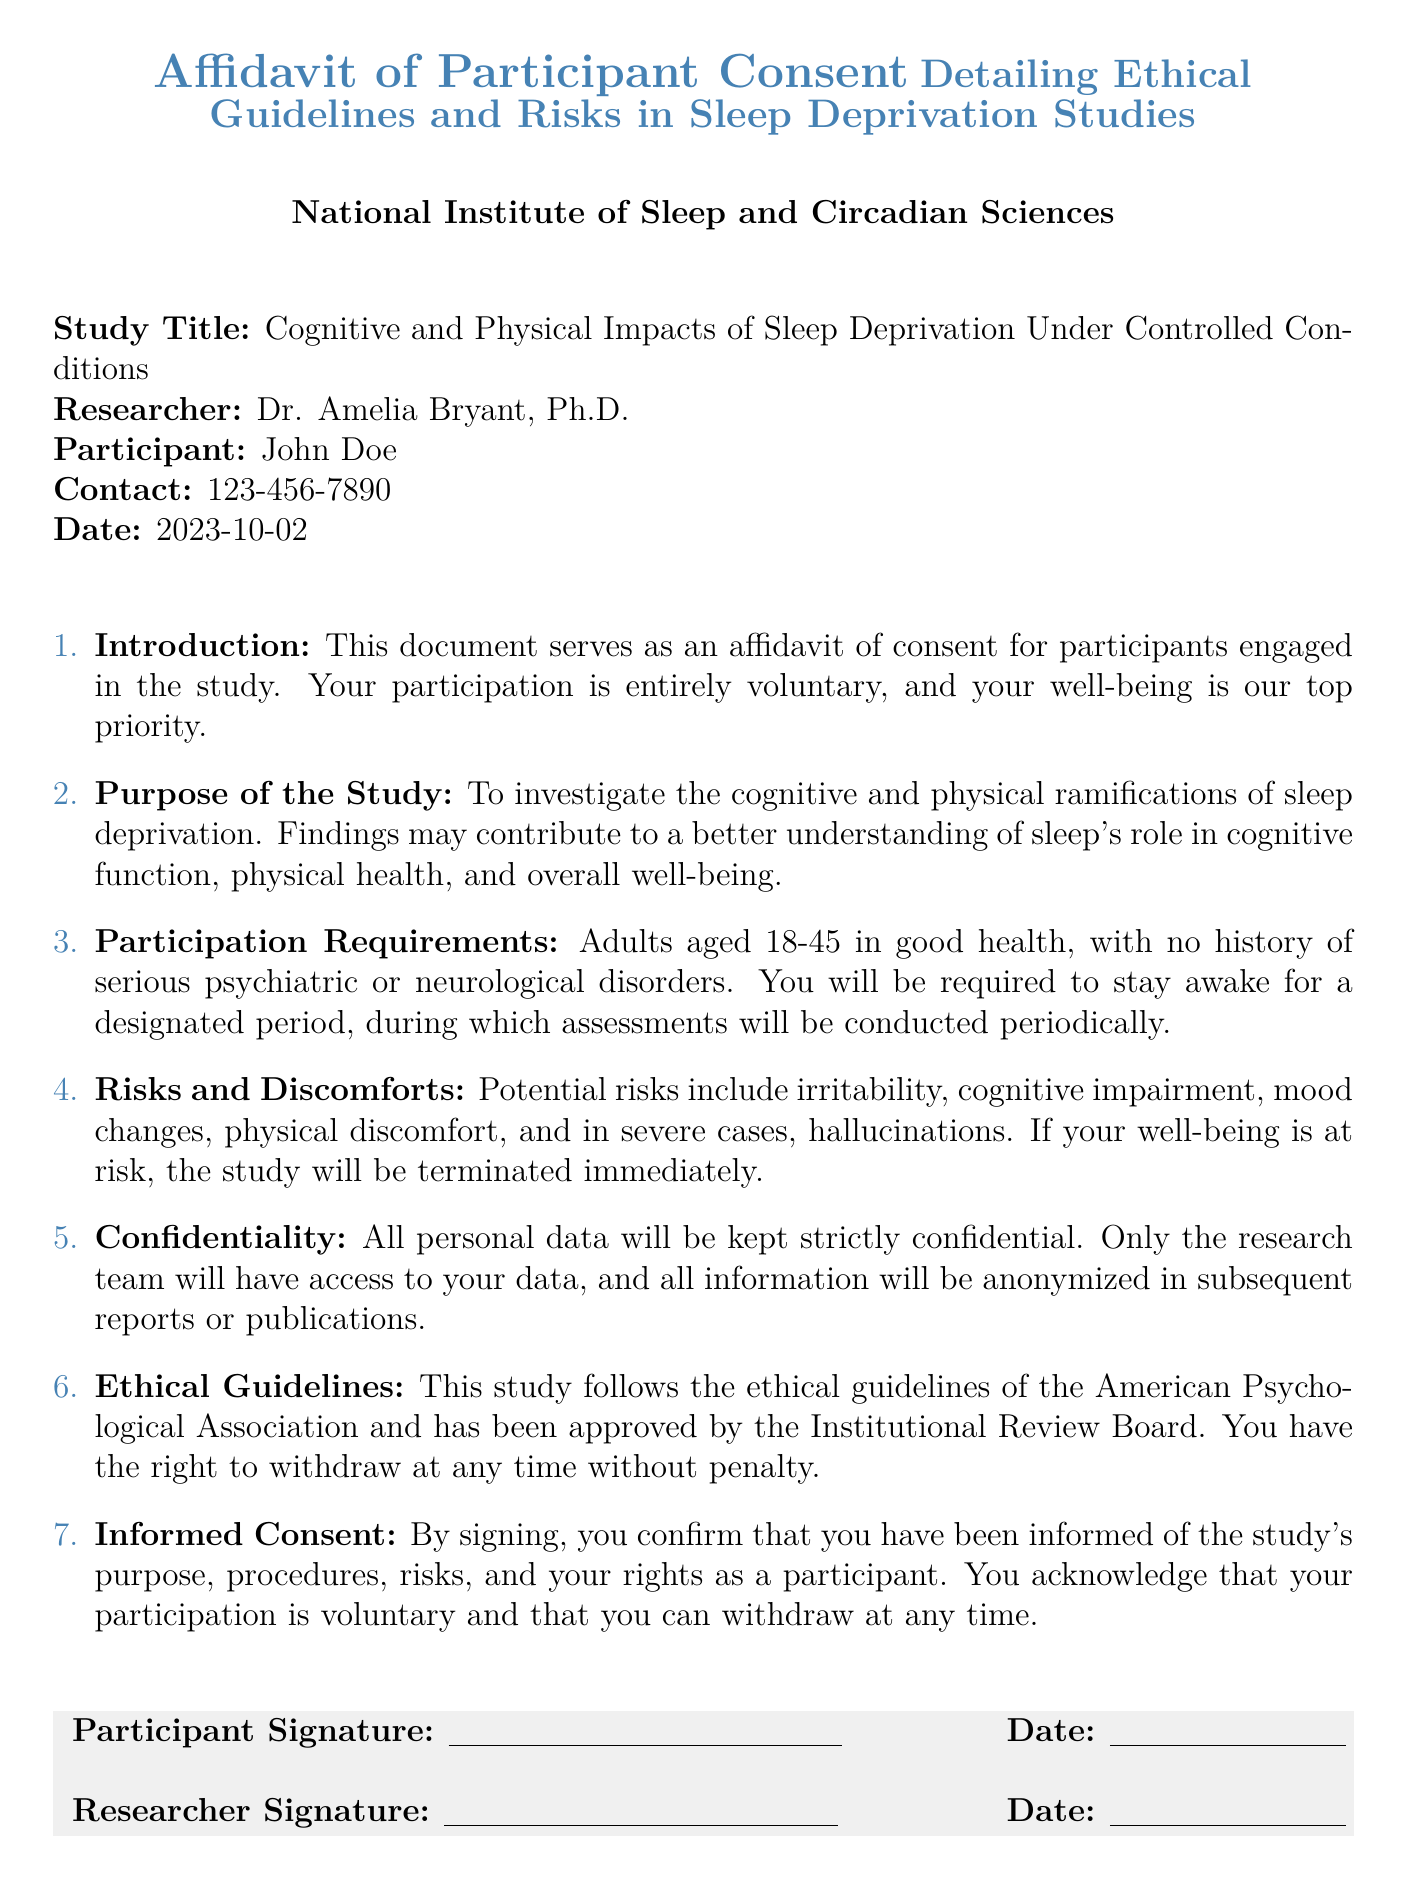what is the study title? The study title is explicitly mentioned at the beginning of the affidavit under "Study Title."
Answer: Cognitive and Physical Impacts of Sleep Deprivation Under Controlled Conditions who is the researcher? The researcher's name is stated in the document, indicating the individual responsible for the study.
Answer: Dr. Amelia Bryant, Ph.D what is the maximum age for participants? The age limit for participants is specified in the "Participation Requirements" section.
Answer: 45 what risks are mentioned in the document? The potential risks are outlined under "Risks and Discomforts," summarizing possible outcomes of participation.
Answer: irritability, cognitive impairment, mood changes, physical discomfort, hallucinations which ethical guidelines does the study follow? The document mentions adherence to specific ethical standards regarding participant treatment and research conduct.
Answer: American Psychological Association what does informed consent confirm? "Informed Consent" details what the participant acknowledges by signing the document.
Answer: that you have been informed of the study's purpose, procedures, risks, and your rights as a participant how can participants withdraw from the study? The document specifies participants' rights regarding their involvement in the study, highlighting their autonomy.
Answer: at any time without penalty who can access personal data? The confidentiality section clarifies who has access to personal participant information.
Answer: only the research team 